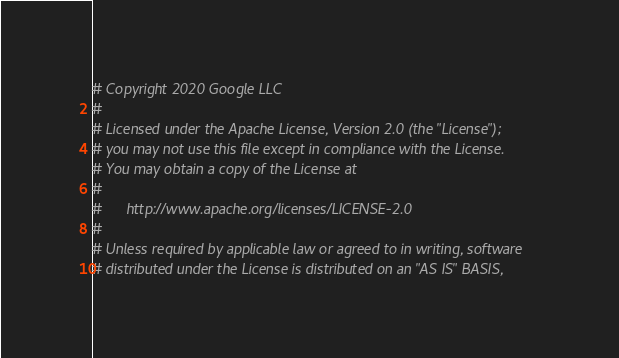Convert code to text. <code><loc_0><loc_0><loc_500><loc_500><_Ruby_># Copyright 2020 Google LLC
#
# Licensed under the Apache License, Version 2.0 (the "License");
# you may not use this file except in compliance with the License.
# You may obtain a copy of the License at
#
#      http://www.apache.org/licenses/LICENSE-2.0
#
# Unless required by applicable law or agreed to in writing, software
# distributed under the License is distributed on an "AS IS" BASIS,</code> 